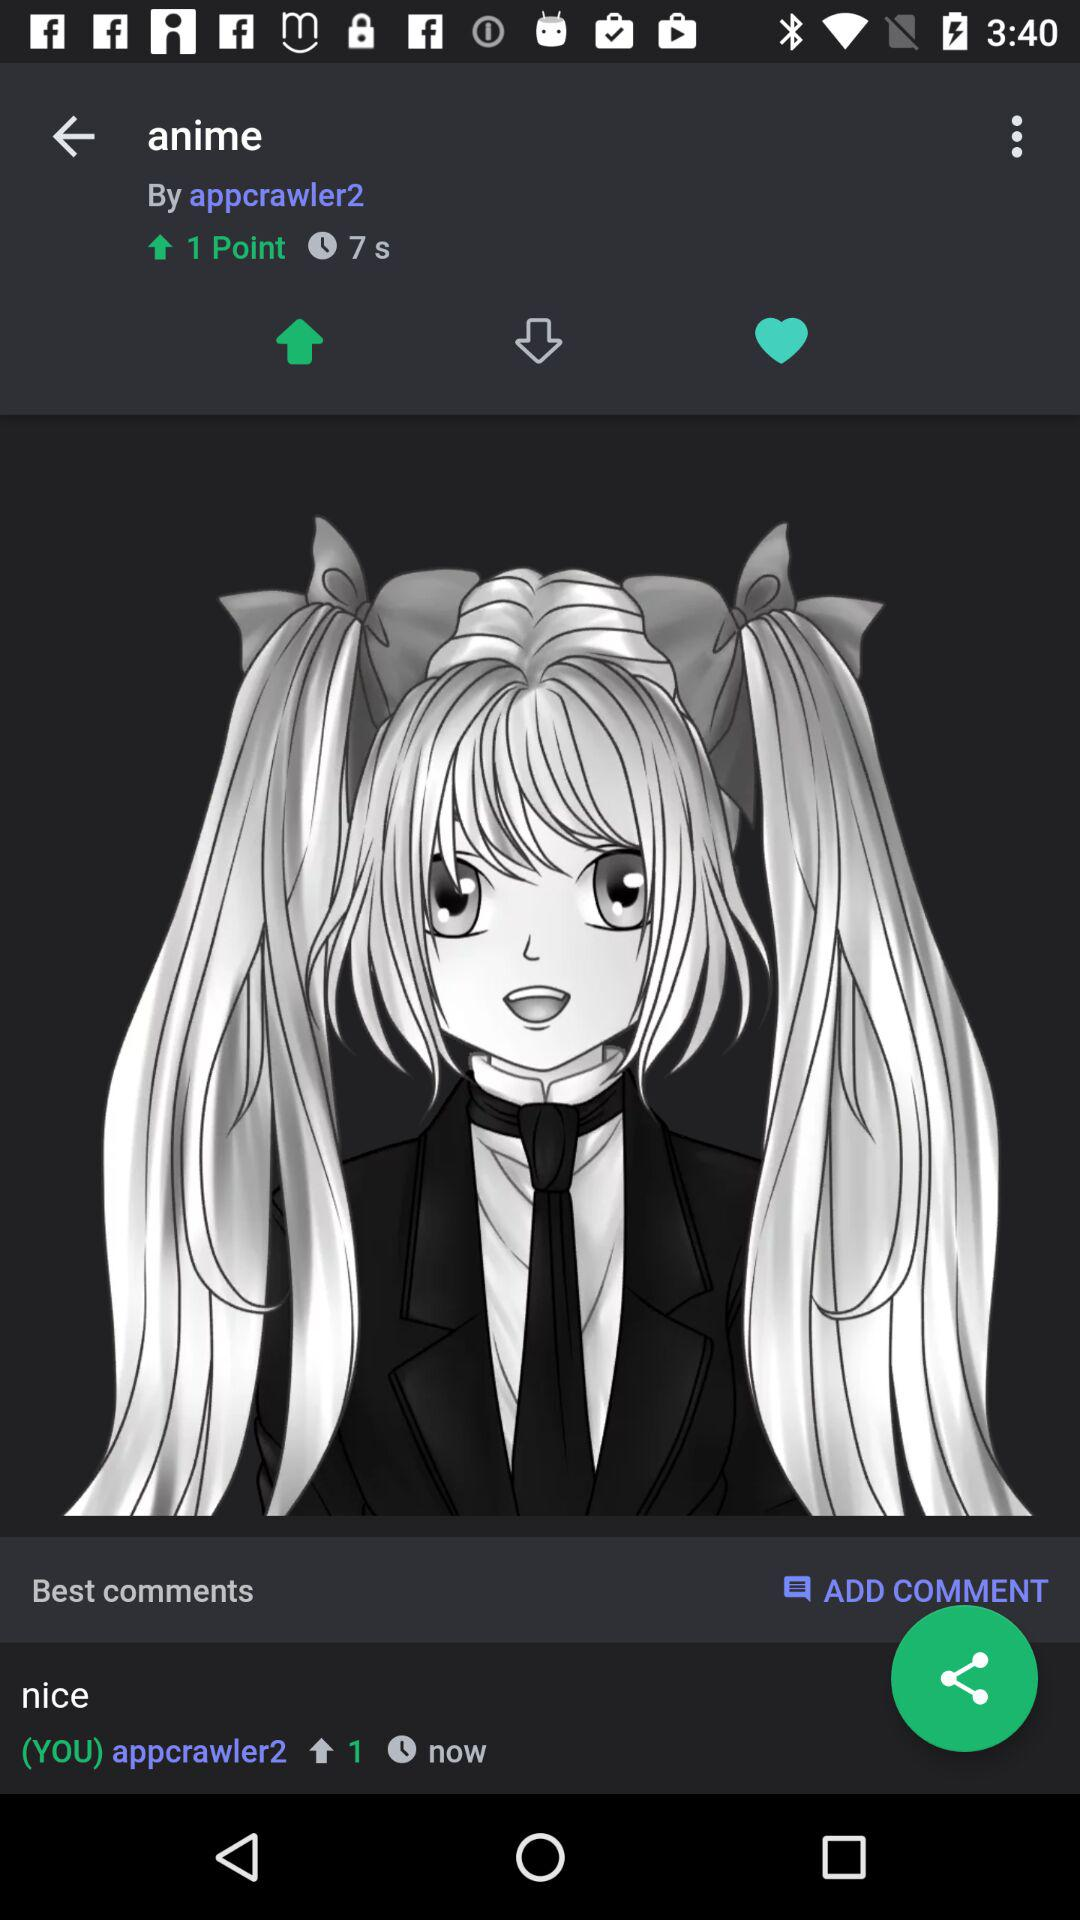How many points are there? There is 1 point. 